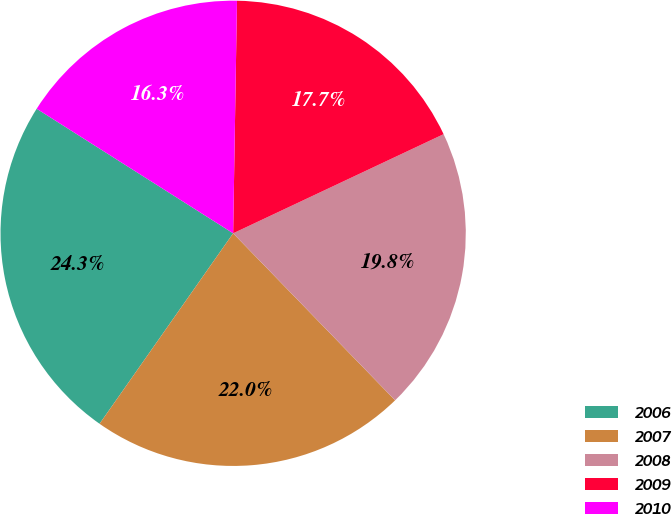Convert chart to OTSL. <chart><loc_0><loc_0><loc_500><loc_500><pie_chart><fcel>2006<fcel>2007<fcel>2008<fcel>2009<fcel>2010<nl><fcel>24.26%<fcel>21.99%<fcel>19.75%<fcel>17.73%<fcel>16.27%<nl></chart> 